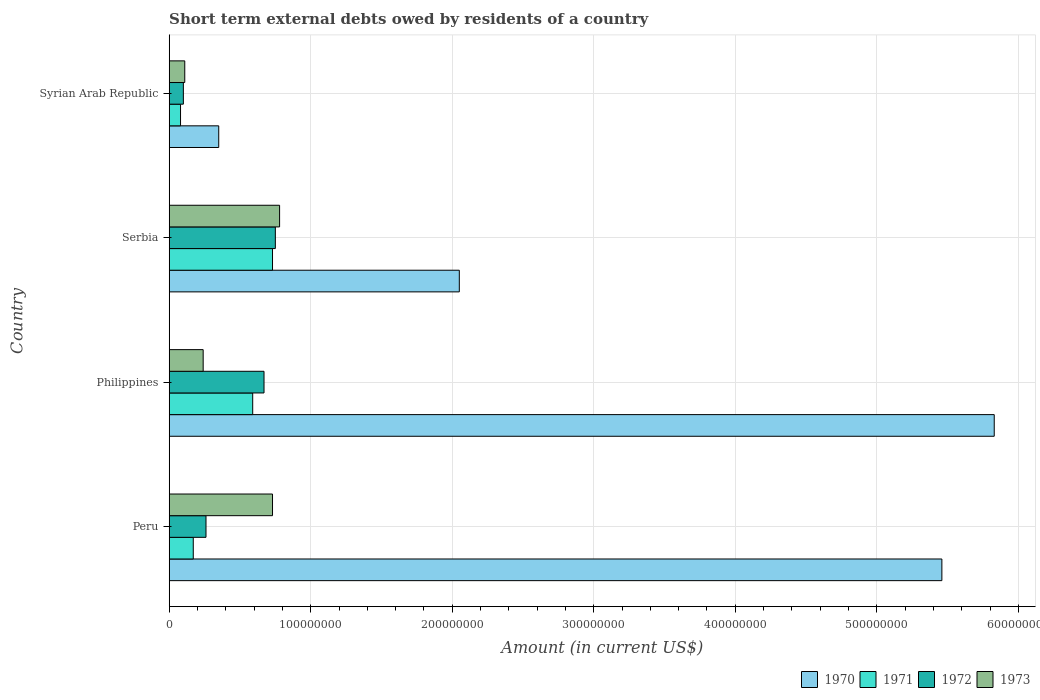How many different coloured bars are there?
Offer a very short reply. 4. How many groups of bars are there?
Your answer should be compact. 4. Are the number of bars on each tick of the Y-axis equal?
Offer a terse response. Yes. How many bars are there on the 1st tick from the top?
Provide a short and direct response. 4. How many bars are there on the 3rd tick from the bottom?
Keep it short and to the point. 4. What is the amount of short-term external debts owed by residents in 1970 in Serbia?
Make the answer very short. 2.05e+08. Across all countries, what is the maximum amount of short-term external debts owed by residents in 1973?
Offer a terse response. 7.80e+07. In which country was the amount of short-term external debts owed by residents in 1970 minimum?
Offer a terse response. Syrian Arab Republic. What is the total amount of short-term external debts owed by residents in 1972 in the graph?
Offer a very short reply. 1.78e+08. What is the difference between the amount of short-term external debts owed by residents in 1972 in Peru and that in Philippines?
Your response must be concise. -4.10e+07. What is the difference between the amount of short-term external debts owed by residents in 1973 in Syrian Arab Republic and the amount of short-term external debts owed by residents in 1972 in Serbia?
Provide a succinct answer. -6.40e+07. What is the average amount of short-term external debts owed by residents in 1970 per country?
Offer a terse response. 3.42e+08. What is the difference between the amount of short-term external debts owed by residents in 1970 and amount of short-term external debts owed by residents in 1971 in Syrian Arab Republic?
Give a very brief answer. 2.70e+07. What is the ratio of the amount of short-term external debts owed by residents in 1973 in Peru to that in Serbia?
Offer a very short reply. 0.94. Is the difference between the amount of short-term external debts owed by residents in 1970 in Peru and Serbia greater than the difference between the amount of short-term external debts owed by residents in 1971 in Peru and Serbia?
Offer a very short reply. Yes. What is the difference between the highest and the second highest amount of short-term external debts owed by residents in 1971?
Provide a succinct answer. 1.40e+07. What is the difference between the highest and the lowest amount of short-term external debts owed by residents in 1972?
Make the answer very short. 6.50e+07. In how many countries, is the amount of short-term external debts owed by residents in 1971 greater than the average amount of short-term external debts owed by residents in 1971 taken over all countries?
Give a very brief answer. 2. Is it the case that in every country, the sum of the amount of short-term external debts owed by residents in 1973 and amount of short-term external debts owed by residents in 1970 is greater than the sum of amount of short-term external debts owed by residents in 1971 and amount of short-term external debts owed by residents in 1972?
Your answer should be very brief. No. What does the 3rd bar from the top in Syrian Arab Republic represents?
Provide a succinct answer. 1971. How many bars are there?
Keep it short and to the point. 16. Are all the bars in the graph horizontal?
Ensure brevity in your answer.  Yes. Does the graph contain any zero values?
Offer a terse response. No. Where does the legend appear in the graph?
Provide a succinct answer. Bottom right. How many legend labels are there?
Offer a terse response. 4. How are the legend labels stacked?
Give a very brief answer. Horizontal. What is the title of the graph?
Provide a succinct answer. Short term external debts owed by residents of a country. Does "1984" appear as one of the legend labels in the graph?
Ensure brevity in your answer.  No. What is the label or title of the Y-axis?
Your answer should be very brief. Country. What is the Amount (in current US$) in 1970 in Peru?
Provide a succinct answer. 5.46e+08. What is the Amount (in current US$) in 1971 in Peru?
Offer a terse response. 1.70e+07. What is the Amount (in current US$) of 1972 in Peru?
Give a very brief answer. 2.60e+07. What is the Amount (in current US$) of 1973 in Peru?
Give a very brief answer. 7.30e+07. What is the Amount (in current US$) of 1970 in Philippines?
Give a very brief answer. 5.83e+08. What is the Amount (in current US$) in 1971 in Philippines?
Keep it short and to the point. 5.90e+07. What is the Amount (in current US$) of 1972 in Philippines?
Your answer should be compact. 6.70e+07. What is the Amount (in current US$) of 1973 in Philippines?
Provide a short and direct response. 2.40e+07. What is the Amount (in current US$) in 1970 in Serbia?
Offer a very short reply. 2.05e+08. What is the Amount (in current US$) in 1971 in Serbia?
Make the answer very short. 7.30e+07. What is the Amount (in current US$) in 1972 in Serbia?
Your answer should be very brief. 7.50e+07. What is the Amount (in current US$) of 1973 in Serbia?
Your answer should be compact. 7.80e+07. What is the Amount (in current US$) of 1970 in Syrian Arab Republic?
Keep it short and to the point. 3.50e+07. What is the Amount (in current US$) in 1973 in Syrian Arab Republic?
Give a very brief answer. 1.10e+07. Across all countries, what is the maximum Amount (in current US$) in 1970?
Offer a terse response. 5.83e+08. Across all countries, what is the maximum Amount (in current US$) of 1971?
Your answer should be compact. 7.30e+07. Across all countries, what is the maximum Amount (in current US$) in 1972?
Offer a terse response. 7.50e+07. Across all countries, what is the maximum Amount (in current US$) in 1973?
Your answer should be compact. 7.80e+07. Across all countries, what is the minimum Amount (in current US$) of 1970?
Give a very brief answer. 3.50e+07. Across all countries, what is the minimum Amount (in current US$) of 1971?
Keep it short and to the point. 8.00e+06. Across all countries, what is the minimum Amount (in current US$) in 1972?
Your response must be concise. 1.00e+07. Across all countries, what is the minimum Amount (in current US$) of 1973?
Offer a terse response. 1.10e+07. What is the total Amount (in current US$) in 1970 in the graph?
Provide a short and direct response. 1.37e+09. What is the total Amount (in current US$) in 1971 in the graph?
Offer a very short reply. 1.57e+08. What is the total Amount (in current US$) of 1972 in the graph?
Keep it short and to the point. 1.78e+08. What is the total Amount (in current US$) of 1973 in the graph?
Your answer should be very brief. 1.86e+08. What is the difference between the Amount (in current US$) in 1970 in Peru and that in Philippines?
Provide a succinct answer. -3.70e+07. What is the difference between the Amount (in current US$) of 1971 in Peru and that in Philippines?
Your response must be concise. -4.20e+07. What is the difference between the Amount (in current US$) of 1972 in Peru and that in Philippines?
Your answer should be very brief. -4.10e+07. What is the difference between the Amount (in current US$) in 1973 in Peru and that in Philippines?
Your response must be concise. 4.90e+07. What is the difference between the Amount (in current US$) in 1970 in Peru and that in Serbia?
Ensure brevity in your answer.  3.41e+08. What is the difference between the Amount (in current US$) of 1971 in Peru and that in Serbia?
Provide a succinct answer. -5.60e+07. What is the difference between the Amount (in current US$) of 1972 in Peru and that in Serbia?
Your answer should be compact. -4.90e+07. What is the difference between the Amount (in current US$) of 1973 in Peru and that in Serbia?
Your response must be concise. -5.00e+06. What is the difference between the Amount (in current US$) of 1970 in Peru and that in Syrian Arab Republic?
Make the answer very short. 5.11e+08. What is the difference between the Amount (in current US$) of 1971 in Peru and that in Syrian Arab Republic?
Your response must be concise. 9.00e+06. What is the difference between the Amount (in current US$) in 1972 in Peru and that in Syrian Arab Republic?
Provide a succinct answer. 1.60e+07. What is the difference between the Amount (in current US$) in 1973 in Peru and that in Syrian Arab Republic?
Provide a short and direct response. 6.20e+07. What is the difference between the Amount (in current US$) in 1970 in Philippines and that in Serbia?
Provide a succinct answer. 3.78e+08. What is the difference between the Amount (in current US$) of 1971 in Philippines and that in Serbia?
Offer a very short reply. -1.40e+07. What is the difference between the Amount (in current US$) of 1972 in Philippines and that in Serbia?
Your answer should be compact. -8.00e+06. What is the difference between the Amount (in current US$) in 1973 in Philippines and that in Serbia?
Ensure brevity in your answer.  -5.40e+07. What is the difference between the Amount (in current US$) in 1970 in Philippines and that in Syrian Arab Republic?
Your response must be concise. 5.48e+08. What is the difference between the Amount (in current US$) in 1971 in Philippines and that in Syrian Arab Republic?
Give a very brief answer. 5.10e+07. What is the difference between the Amount (in current US$) in 1972 in Philippines and that in Syrian Arab Republic?
Your answer should be compact. 5.70e+07. What is the difference between the Amount (in current US$) in 1973 in Philippines and that in Syrian Arab Republic?
Your answer should be compact. 1.30e+07. What is the difference between the Amount (in current US$) of 1970 in Serbia and that in Syrian Arab Republic?
Offer a very short reply. 1.70e+08. What is the difference between the Amount (in current US$) in 1971 in Serbia and that in Syrian Arab Republic?
Provide a short and direct response. 6.50e+07. What is the difference between the Amount (in current US$) in 1972 in Serbia and that in Syrian Arab Republic?
Offer a very short reply. 6.50e+07. What is the difference between the Amount (in current US$) in 1973 in Serbia and that in Syrian Arab Republic?
Give a very brief answer. 6.70e+07. What is the difference between the Amount (in current US$) in 1970 in Peru and the Amount (in current US$) in 1971 in Philippines?
Your answer should be compact. 4.87e+08. What is the difference between the Amount (in current US$) in 1970 in Peru and the Amount (in current US$) in 1972 in Philippines?
Your answer should be very brief. 4.79e+08. What is the difference between the Amount (in current US$) of 1970 in Peru and the Amount (in current US$) of 1973 in Philippines?
Keep it short and to the point. 5.22e+08. What is the difference between the Amount (in current US$) in 1971 in Peru and the Amount (in current US$) in 1972 in Philippines?
Keep it short and to the point. -5.00e+07. What is the difference between the Amount (in current US$) in 1971 in Peru and the Amount (in current US$) in 1973 in Philippines?
Ensure brevity in your answer.  -7.00e+06. What is the difference between the Amount (in current US$) of 1972 in Peru and the Amount (in current US$) of 1973 in Philippines?
Provide a succinct answer. 2.00e+06. What is the difference between the Amount (in current US$) of 1970 in Peru and the Amount (in current US$) of 1971 in Serbia?
Provide a short and direct response. 4.73e+08. What is the difference between the Amount (in current US$) in 1970 in Peru and the Amount (in current US$) in 1972 in Serbia?
Your answer should be very brief. 4.71e+08. What is the difference between the Amount (in current US$) in 1970 in Peru and the Amount (in current US$) in 1973 in Serbia?
Offer a terse response. 4.68e+08. What is the difference between the Amount (in current US$) of 1971 in Peru and the Amount (in current US$) of 1972 in Serbia?
Ensure brevity in your answer.  -5.80e+07. What is the difference between the Amount (in current US$) of 1971 in Peru and the Amount (in current US$) of 1973 in Serbia?
Your answer should be very brief. -6.10e+07. What is the difference between the Amount (in current US$) in 1972 in Peru and the Amount (in current US$) in 1973 in Serbia?
Offer a very short reply. -5.20e+07. What is the difference between the Amount (in current US$) of 1970 in Peru and the Amount (in current US$) of 1971 in Syrian Arab Republic?
Offer a terse response. 5.38e+08. What is the difference between the Amount (in current US$) in 1970 in Peru and the Amount (in current US$) in 1972 in Syrian Arab Republic?
Provide a succinct answer. 5.36e+08. What is the difference between the Amount (in current US$) in 1970 in Peru and the Amount (in current US$) in 1973 in Syrian Arab Republic?
Give a very brief answer. 5.35e+08. What is the difference between the Amount (in current US$) of 1971 in Peru and the Amount (in current US$) of 1972 in Syrian Arab Republic?
Your answer should be compact. 7.00e+06. What is the difference between the Amount (in current US$) in 1972 in Peru and the Amount (in current US$) in 1973 in Syrian Arab Republic?
Offer a very short reply. 1.50e+07. What is the difference between the Amount (in current US$) in 1970 in Philippines and the Amount (in current US$) in 1971 in Serbia?
Provide a succinct answer. 5.10e+08. What is the difference between the Amount (in current US$) of 1970 in Philippines and the Amount (in current US$) of 1972 in Serbia?
Provide a succinct answer. 5.08e+08. What is the difference between the Amount (in current US$) in 1970 in Philippines and the Amount (in current US$) in 1973 in Serbia?
Your answer should be very brief. 5.05e+08. What is the difference between the Amount (in current US$) of 1971 in Philippines and the Amount (in current US$) of 1972 in Serbia?
Ensure brevity in your answer.  -1.60e+07. What is the difference between the Amount (in current US$) in 1971 in Philippines and the Amount (in current US$) in 1973 in Serbia?
Provide a succinct answer. -1.90e+07. What is the difference between the Amount (in current US$) in 1972 in Philippines and the Amount (in current US$) in 1973 in Serbia?
Offer a terse response. -1.10e+07. What is the difference between the Amount (in current US$) of 1970 in Philippines and the Amount (in current US$) of 1971 in Syrian Arab Republic?
Give a very brief answer. 5.75e+08. What is the difference between the Amount (in current US$) in 1970 in Philippines and the Amount (in current US$) in 1972 in Syrian Arab Republic?
Ensure brevity in your answer.  5.73e+08. What is the difference between the Amount (in current US$) of 1970 in Philippines and the Amount (in current US$) of 1973 in Syrian Arab Republic?
Provide a succinct answer. 5.72e+08. What is the difference between the Amount (in current US$) in 1971 in Philippines and the Amount (in current US$) in 1972 in Syrian Arab Republic?
Your response must be concise. 4.90e+07. What is the difference between the Amount (in current US$) in 1971 in Philippines and the Amount (in current US$) in 1973 in Syrian Arab Republic?
Give a very brief answer. 4.80e+07. What is the difference between the Amount (in current US$) in 1972 in Philippines and the Amount (in current US$) in 1973 in Syrian Arab Republic?
Give a very brief answer. 5.60e+07. What is the difference between the Amount (in current US$) of 1970 in Serbia and the Amount (in current US$) of 1971 in Syrian Arab Republic?
Your response must be concise. 1.97e+08. What is the difference between the Amount (in current US$) in 1970 in Serbia and the Amount (in current US$) in 1972 in Syrian Arab Republic?
Your response must be concise. 1.95e+08. What is the difference between the Amount (in current US$) of 1970 in Serbia and the Amount (in current US$) of 1973 in Syrian Arab Republic?
Ensure brevity in your answer.  1.94e+08. What is the difference between the Amount (in current US$) of 1971 in Serbia and the Amount (in current US$) of 1972 in Syrian Arab Republic?
Ensure brevity in your answer.  6.30e+07. What is the difference between the Amount (in current US$) in 1971 in Serbia and the Amount (in current US$) in 1973 in Syrian Arab Republic?
Offer a very short reply. 6.20e+07. What is the difference between the Amount (in current US$) in 1972 in Serbia and the Amount (in current US$) in 1973 in Syrian Arab Republic?
Ensure brevity in your answer.  6.40e+07. What is the average Amount (in current US$) in 1970 per country?
Your answer should be very brief. 3.42e+08. What is the average Amount (in current US$) in 1971 per country?
Keep it short and to the point. 3.92e+07. What is the average Amount (in current US$) of 1972 per country?
Your answer should be compact. 4.45e+07. What is the average Amount (in current US$) of 1973 per country?
Give a very brief answer. 4.65e+07. What is the difference between the Amount (in current US$) in 1970 and Amount (in current US$) in 1971 in Peru?
Your answer should be compact. 5.29e+08. What is the difference between the Amount (in current US$) of 1970 and Amount (in current US$) of 1972 in Peru?
Keep it short and to the point. 5.20e+08. What is the difference between the Amount (in current US$) of 1970 and Amount (in current US$) of 1973 in Peru?
Offer a very short reply. 4.73e+08. What is the difference between the Amount (in current US$) in 1971 and Amount (in current US$) in 1972 in Peru?
Give a very brief answer. -9.00e+06. What is the difference between the Amount (in current US$) of 1971 and Amount (in current US$) of 1973 in Peru?
Provide a succinct answer. -5.60e+07. What is the difference between the Amount (in current US$) in 1972 and Amount (in current US$) in 1973 in Peru?
Give a very brief answer. -4.70e+07. What is the difference between the Amount (in current US$) in 1970 and Amount (in current US$) in 1971 in Philippines?
Your answer should be compact. 5.24e+08. What is the difference between the Amount (in current US$) of 1970 and Amount (in current US$) of 1972 in Philippines?
Your answer should be compact. 5.16e+08. What is the difference between the Amount (in current US$) of 1970 and Amount (in current US$) of 1973 in Philippines?
Your answer should be compact. 5.59e+08. What is the difference between the Amount (in current US$) in 1971 and Amount (in current US$) in 1972 in Philippines?
Offer a very short reply. -8.00e+06. What is the difference between the Amount (in current US$) in 1971 and Amount (in current US$) in 1973 in Philippines?
Ensure brevity in your answer.  3.50e+07. What is the difference between the Amount (in current US$) in 1972 and Amount (in current US$) in 1973 in Philippines?
Provide a short and direct response. 4.30e+07. What is the difference between the Amount (in current US$) of 1970 and Amount (in current US$) of 1971 in Serbia?
Make the answer very short. 1.32e+08. What is the difference between the Amount (in current US$) in 1970 and Amount (in current US$) in 1972 in Serbia?
Your response must be concise. 1.30e+08. What is the difference between the Amount (in current US$) of 1970 and Amount (in current US$) of 1973 in Serbia?
Offer a very short reply. 1.27e+08. What is the difference between the Amount (in current US$) of 1971 and Amount (in current US$) of 1972 in Serbia?
Make the answer very short. -2.00e+06. What is the difference between the Amount (in current US$) of 1971 and Amount (in current US$) of 1973 in Serbia?
Your answer should be very brief. -5.00e+06. What is the difference between the Amount (in current US$) in 1972 and Amount (in current US$) in 1973 in Serbia?
Provide a succinct answer. -3.00e+06. What is the difference between the Amount (in current US$) of 1970 and Amount (in current US$) of 1971 in Syrian Arab Republic?
Your answer should be very brief. 2.70e+07. What is the difference between the Amount (in current US$) of 1970 and Amount (in current US$) of 1972 in Syrian Arab Republic?
Keep it short and to the point. 2.50e+07. What is the difference between the Amount (in current US$) in 1970 and Amount (in current US$) in 1973 in Syrian Arab Republic?
Your response must be concise. 2.40e+07. What is the difference between the Amount (in current US$) in 1971 and Amount (in current US$) in 1972 in Syrian Arab Republic?
Offer a terse response. -2.00e+06. What is the ratio of the Amount (in current US$) of 1970 in Peru to that in Philippines?
Provide a succinct answer. 0.94. What is the ratio of the Amount (in current US$) of 1971 in Peru to that in Philippines?
Your answer should be compact. 0.29. What is the ratio of the Amount (in current US$) in 1972 in Peru to that in Philippines?
Keep it short and to the point. 0.39. What is the ratio of the Amount (in current US$) of 1973 in Peru to that in Philippines?
Ensure brevity in your answer.  3.04. What is the ratio of the Amount (in current US$) of 1970 in Peru to that in Serbia?
Ensure brevity in your answer.  2.66. What is the ratio of the Amount (in current US$) in 1971 in Peru to that in Serbia?
Ensure brevity in your answer.  0.23. What is the ratio of the Amount (in current US$) in 1972 in Peru to that in Serbia?
Your answer should be compact. 0.35. What is the ratio of the Amount (in current US$) of 1973 in Peru to that in Serbia?
Offer a terse response. 0.94. What is the ratio of the Amount (in current US$) in 1971 in Peru to that in Syrian Arab Republic?
Keep it short and to the point. 2.12. What is the ratio of the Amount (in current US$) of 1972 in Peru to that in Syrian Arab Republic?
Your response must be concise. 2.6. What is the ratio of the Amount (in current US$) in 1973 in Peru to that in Syrian Arab Republic?
Offer a terse response. 6.64. What is the ratio of the Amount (in current US$) of 1970 in Philippines to that in Serbia?
Offer a terse response. 2.84. What is the ratio of the Amount (in current US$) of 1971 in Philippines to that in Serbia?
Ensure brevity in your answer.  0.81. What is the ratio of the Amount (in current US$) of 1972 in Philippines to that in Serbia?
Offer a terse response. 0.89. What is the ratio of the Amount (in current US$) in 1973 in Philippines to that in Serbia?
Provide a short and direct response. 0.31. What is the ratio of the Amount (in current US$) in 1970 in Philippines to that in Syrian Arab Republic?
Give a very brief answer. 16.66. What is the ratio of the Amount (in current US$) of 1971 in Philippines to that in Syrian Arab Republic?
Your answer should be compact. 7.38. What is the ratio of the Amount (in current US$) in 1972 in Philippines to that in Syrian Arab Republic?
Your response must be concise. 6.7. What is the ratio of the Amount (in current US$) of 1973 in Philippines to that in Syrian Arab Republic?
Provide a succinct answer. 2.18. What is the ratio of the Amount (in current US$) of 1970 in Serbia to that in Syrian Arab Republic?
Your answer should be compact. 5.86. What is the ratio of the Amount (in current US$) of 1971 in Serbia to that in Syrian Arab Republic?
Your answer should be very brief. 9.12. What is the ratio of the Amount (in current US$) of 1973 in Serbia to that in Syrian Arab Republic?
Offer a terse response. 7.09. What is the difference between the highest and the second highest Amount (in current US$) of 1970?
Your answer should be compact. 3.70e+07. What is the difference between the highest and the second highest Amount (in current US$) of 1971?
Provide a succinct answer. 1.40e+07. What is the difference between the highest and the second highest Amount (in current US$) in 1973?
Provide a short and direct response. 5.00e+06. What is the difference between the highest and the lowest Amount (in current US$) in 1970?
Keep it short and to the point. 5.48e+08. What is the difference between the highest and the lowest Amount (in current US$) in 1971?
Provide a short and direct response. 6.50e+07. What is the difference between the highest and the lowest Amount (in current US$) of 1972?
Offer a very short reply. 6.50e+07. What is the difference between the highest and the lowest Amount (in current US$) in 1973?
Your response must be concise. 6.70e+07. 